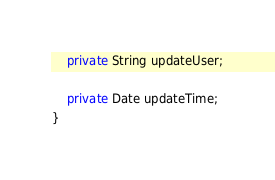Convert code to text. <code><loc_0><loc_0><loc_500><loc_500><_Java_>
    private String updateUser;

    private Date updateTime;
}
</code> 